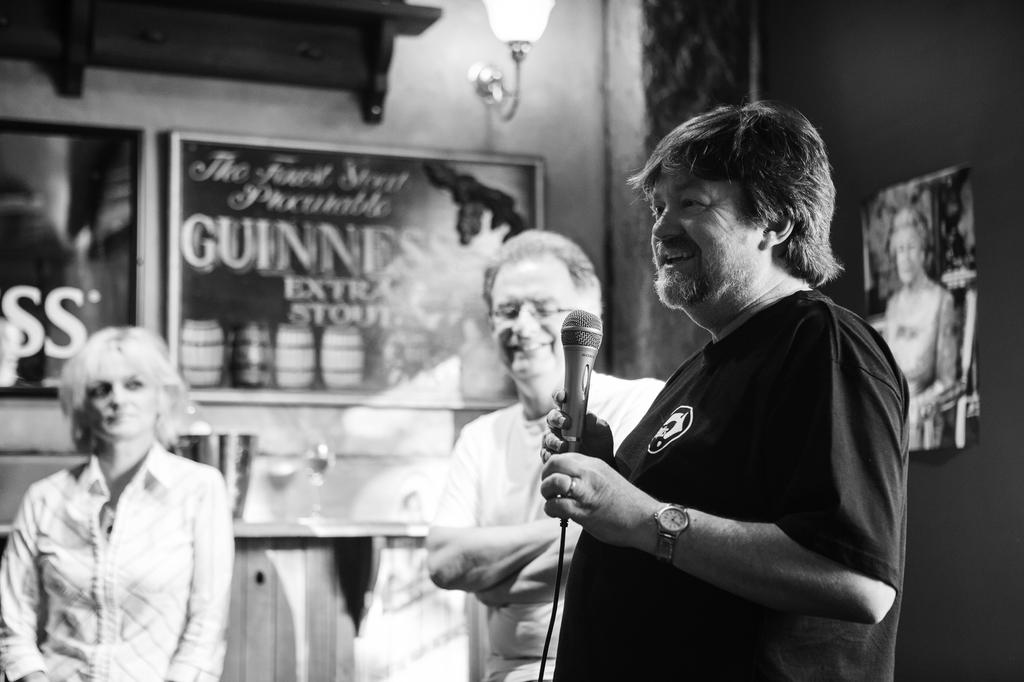How many people are in the image? There are two persons in the image. Can you describe one of the individuals in the image? There is a woman in the image. What is one of the persons doing in the image? One person is catching a microphone. What type of pail can be seen in the image? There is no pail present in the image. Is there an alley visible in the image? There is no alley visible in the image. 